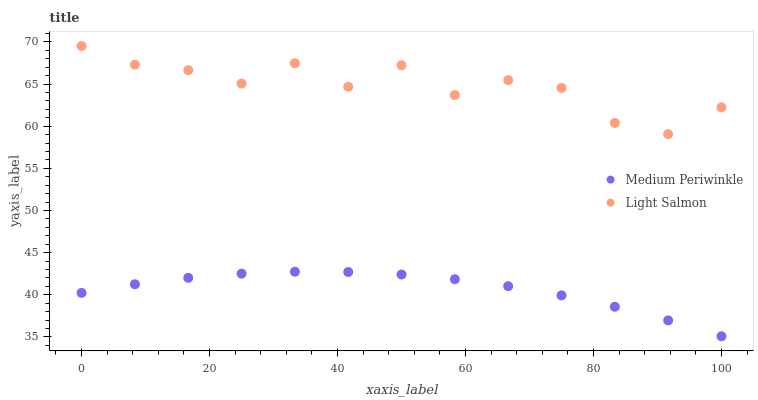Does Medium Periwinkle have the minimum area under the curve?
Answer yes or no. Yes. Does Light Salmon have the maximum area under the curve?
Answer yes or no. Yes. Does Medium Periwinkle have the maximum area under the curve?
Answer yes or no. No. Is Medium Periwinkle the smoothest?
Answer yes or no. Yes. Is Light Salmon the roughest?
Answer yes or no. Yes. Is Medium Periwinkle the roughest?
Answer yes or no. No. Does Medium Periwinkle have the lowest value?
Answer yes or no. Yes. Does Light Salmon have the highest value?
Answer yes or no. Yes. Does Medium Periwinkle have the highest value?
Answer yes or no. No. Is Medium Periwinkle less than Light Salmon?
Answer yes or no. Yes. Is Light Salmon greater than Medium Periwinkle?
Answer yes or no. Yes. Does Medium Periwinkle intersect Light Salmon?
Answer yes or no. No. 